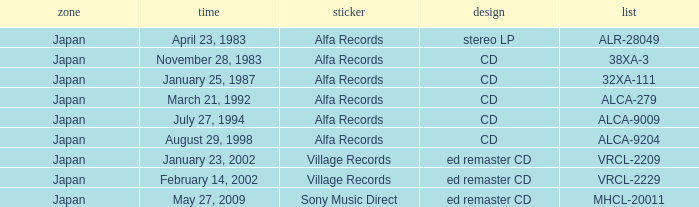I'm looking to parse the entire table for insights. Could you assist me with that? {'header': ['zone', 'time', 'sticker', 'design', 'list'], 'rows': [['Japan', 'April 23, 1983', 'Alfa Records', 'stereo LP', 'ALR-28049'], ['Japan', 'November 28, 1983', 'Alfa Records', 'CD', '38XA-3'], ['Japan', 'January 25, 1987', 'Alfa Records', 'CD', '32XA-111'], ['Japan', 'March 21, 1992', 'Alfa Records', 'CD', 'ALCA-279'], ['Japan', 'July 27, 1994', 'Alfa Records', 'CD', 'ALCA-9009'], ['Japan', 'August 29, 1998', 'Alfa Records', 'CD', 'ALCA-9204'], ['Japan', 'January 23, 2002', 'Village Records', 'ed remaster CD', 'VRCL-2209'], ['Japan', 'February 14, 2002', 'Village Records', 'ed remaster CD', 'VRCL-2229'], ['Japan', 'May 27, 2009', 'Sony Music Direct', 'ed remaster CD', 'MHCL-20011']]} On which date can the stereo lp format be found? April 23, 1983. 